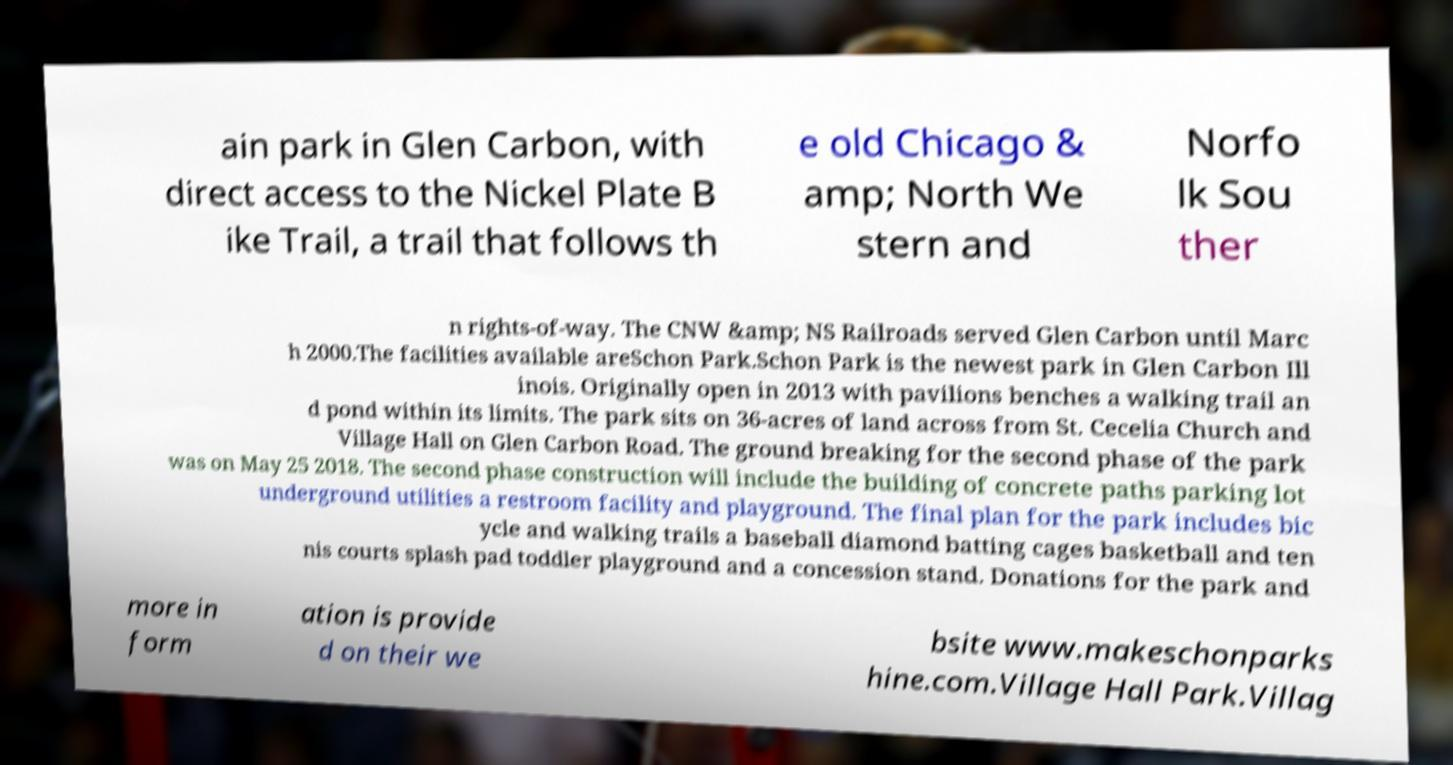For documentation purposes, I need the text within this image transcribed. Could you provide that? ain park in Glen Carbon, with direct access to the Nickel Plate B ike Trail, a trail that follows th e old Chicago & amp; North We stern and Norfo lk Sou ther n rights-of-way. The CNW &amp; NS Railroads served Glen Carbon until Marc h 2000.The facilities available areSchon Park.Schon Park is the newest park in Glen Carbon Ill inois. Originally open in 2013 with pavilions benches a walking trail an d pond within its limits. The park sits on 36-acres of land across from St. Cecelia Church and Village Hall on Glen Carbon Road. The ground breaking for the second phase of the park was on May 25 2018. The second phase construction will include the building of concrete paths parking lot underground utilities a restroom facility and playground. The final plan for the park includes bic ycle and walking trails a baseball diamond batting cages basketball and ten nis courts splash pad toddler playground and a concession stand. Donations for the park and more in form ation is provide d on their we bsite www.makeschonparks hine.com.Village Hall Park.Villag 